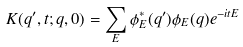<formula> <loc_0><loc_0><loc_500><loc_500>K ( q ^ { \prime } , t ; q , 0 ) = \sum _ { E } \phi ^ { * } _ { E } ( q ^ { \prime } ) \phi _ { E } ( q ) e ^ { - i t E }</formula> 